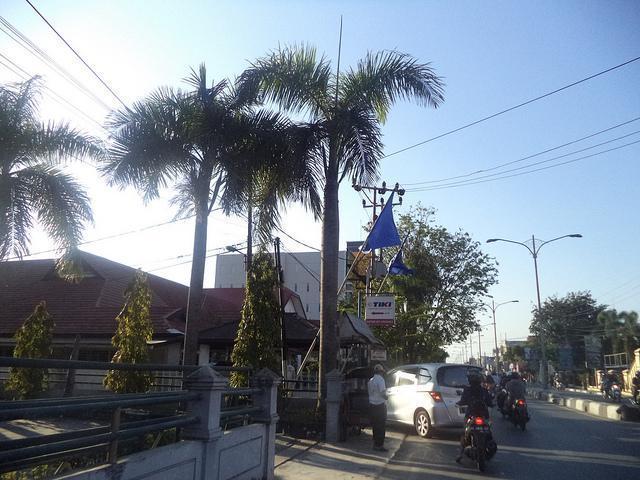How many zebras have all of their feet in the grass?
Give a very brief answer. 0. 